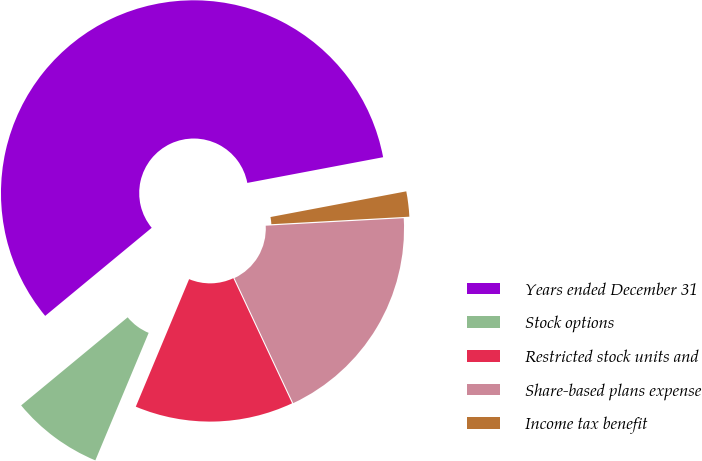<chart> <loc_0><loc_0><loc_500><loc_500><pie_chart><fcel>Years ended December 31<fcel>Stock options<fcel>Restricted stock units and<fcel>Share-based plans expense<fcel>Income tax benefit<nl><fcel>58.02%<fcel>7.7%<fcel>13.29%<fcel>18.88%<fcel>2.11%<nl></chart> 